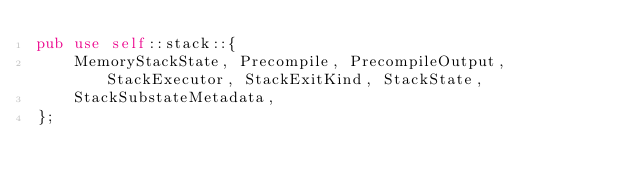<code> <loc_0><loc_0><loc_500><loc_500><_Rust_>pub use self::stack::{
	MemoryStackState, Precompile, PrecompileOutput, StackExecutor, StackExitKind, StackState,
	StackSubstateMetadata,
};
</code> 